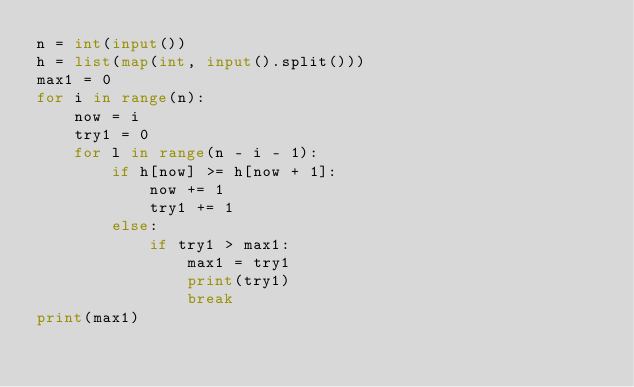Convert code to text. <code><loc_0><loc_0><loc_500><loc_500><_Python_>n = int(input())
h = list(map(int, input().split()))
max1 = 0
for i in range(n):
    now = i
    try1 = 0
    for l in range(n - i - 1):
        if h[now] >= h[now + 1]:
            now += 1
            try1 += 1
        else:
            if try1 > max1:
                max1 = try1
                print(try1)
                break
print(max1)
</code> 